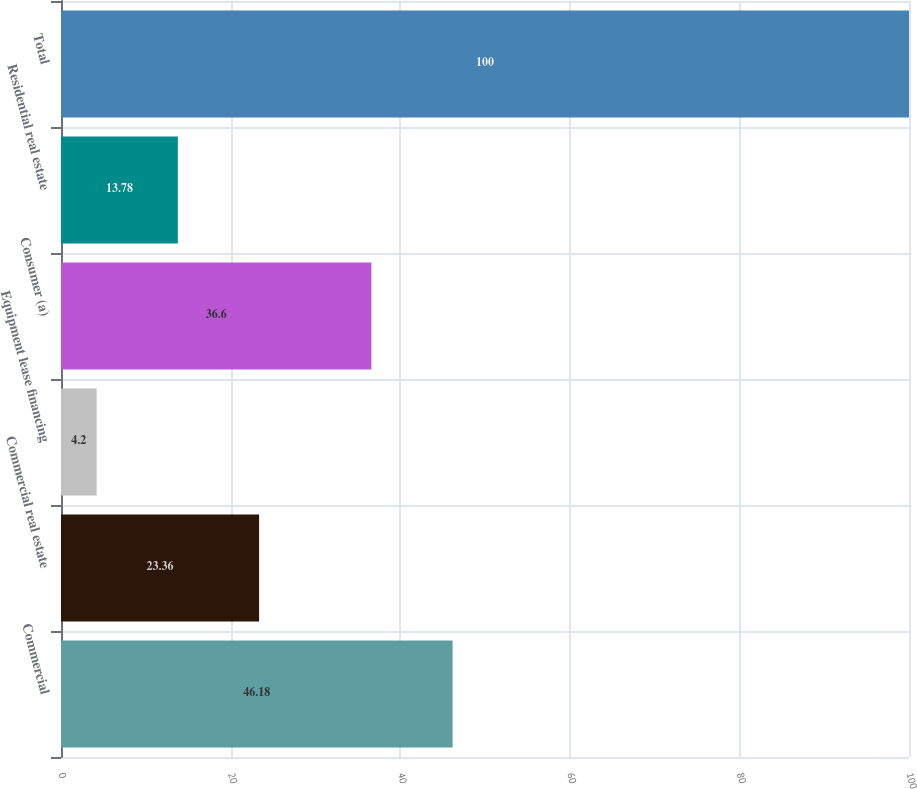<chart> <loc_0><loc_0><loc_500><loc_500><bar_chart><fcel>Commercial<fcel>Commercial real estate<fcel>Equipment lease financing<fcel>Consumer (a)<fcel>Residential real estate<fcel>Total<nl><fcel>46.18<fcel>23.36<fcel>4.2<fcel>36.6<fcel>13.78<fcel>100<nl></chart> 